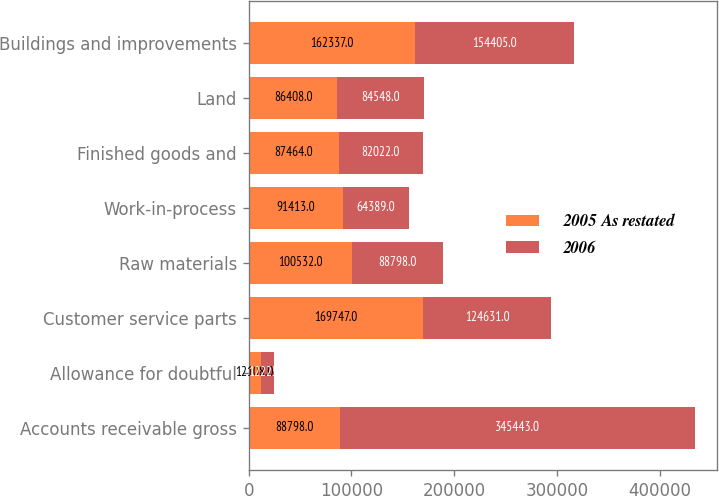Convert chart to OTSL. <chart><loc_0><loc_0><loc_500><loc_500><stacked_bar_chart><ecel><fcel>Accounts receivable gross<fcel>Allowance for doubtful<fcel>Customer service parts<fcel>Raw materials<fcel>Work-in-process<fcel>Finished goods and<fcel>Land<fcel>Buildings and improvements<nl><fcel>2005 As restated<fcel>88798<fcel>12108<fcel>169747<fcel>100532<fcel>91413<fcel>87464<fcel>86408<fcel>162337<nl><fcel>2006<fcel>345443<fcel>12225<fcel>124631<fcel>88798<fcel>64389<fcel>82022<fcel>84548<fcel>154405<nl></chart> 